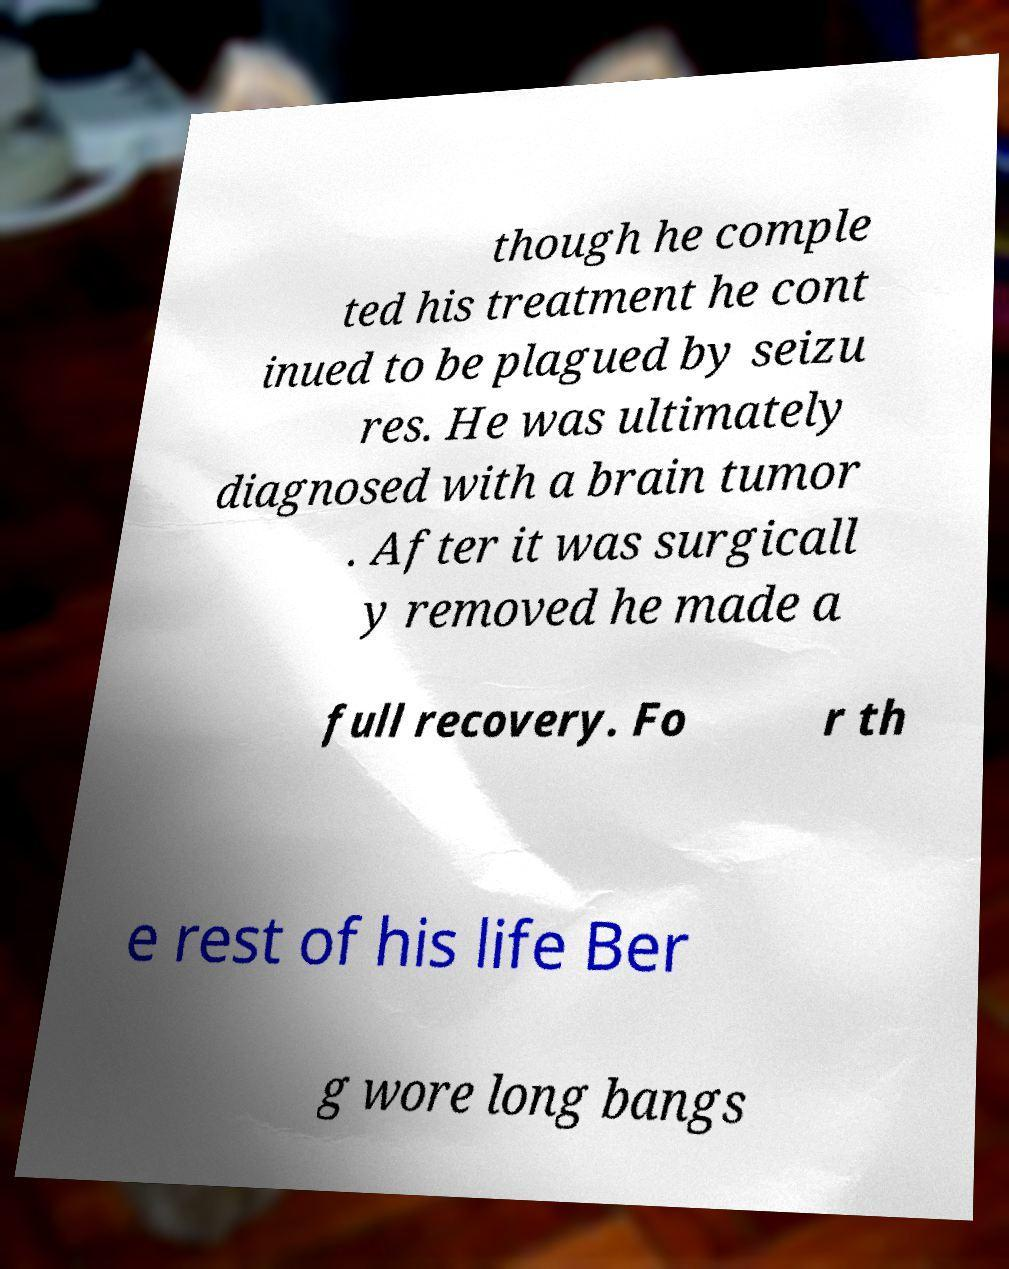Can you read and provide the text displayed in the image?This photo seems to have some interesting text. Can you extract and type it out for me? though he comple ted his treatment he cont inued to be plagued by seizu res. He was ultimately diagnosed with a brain tumor . After it was surgicall y removed he made a full recovery. Fo r th e rest of his life Ber g wore long bangs 